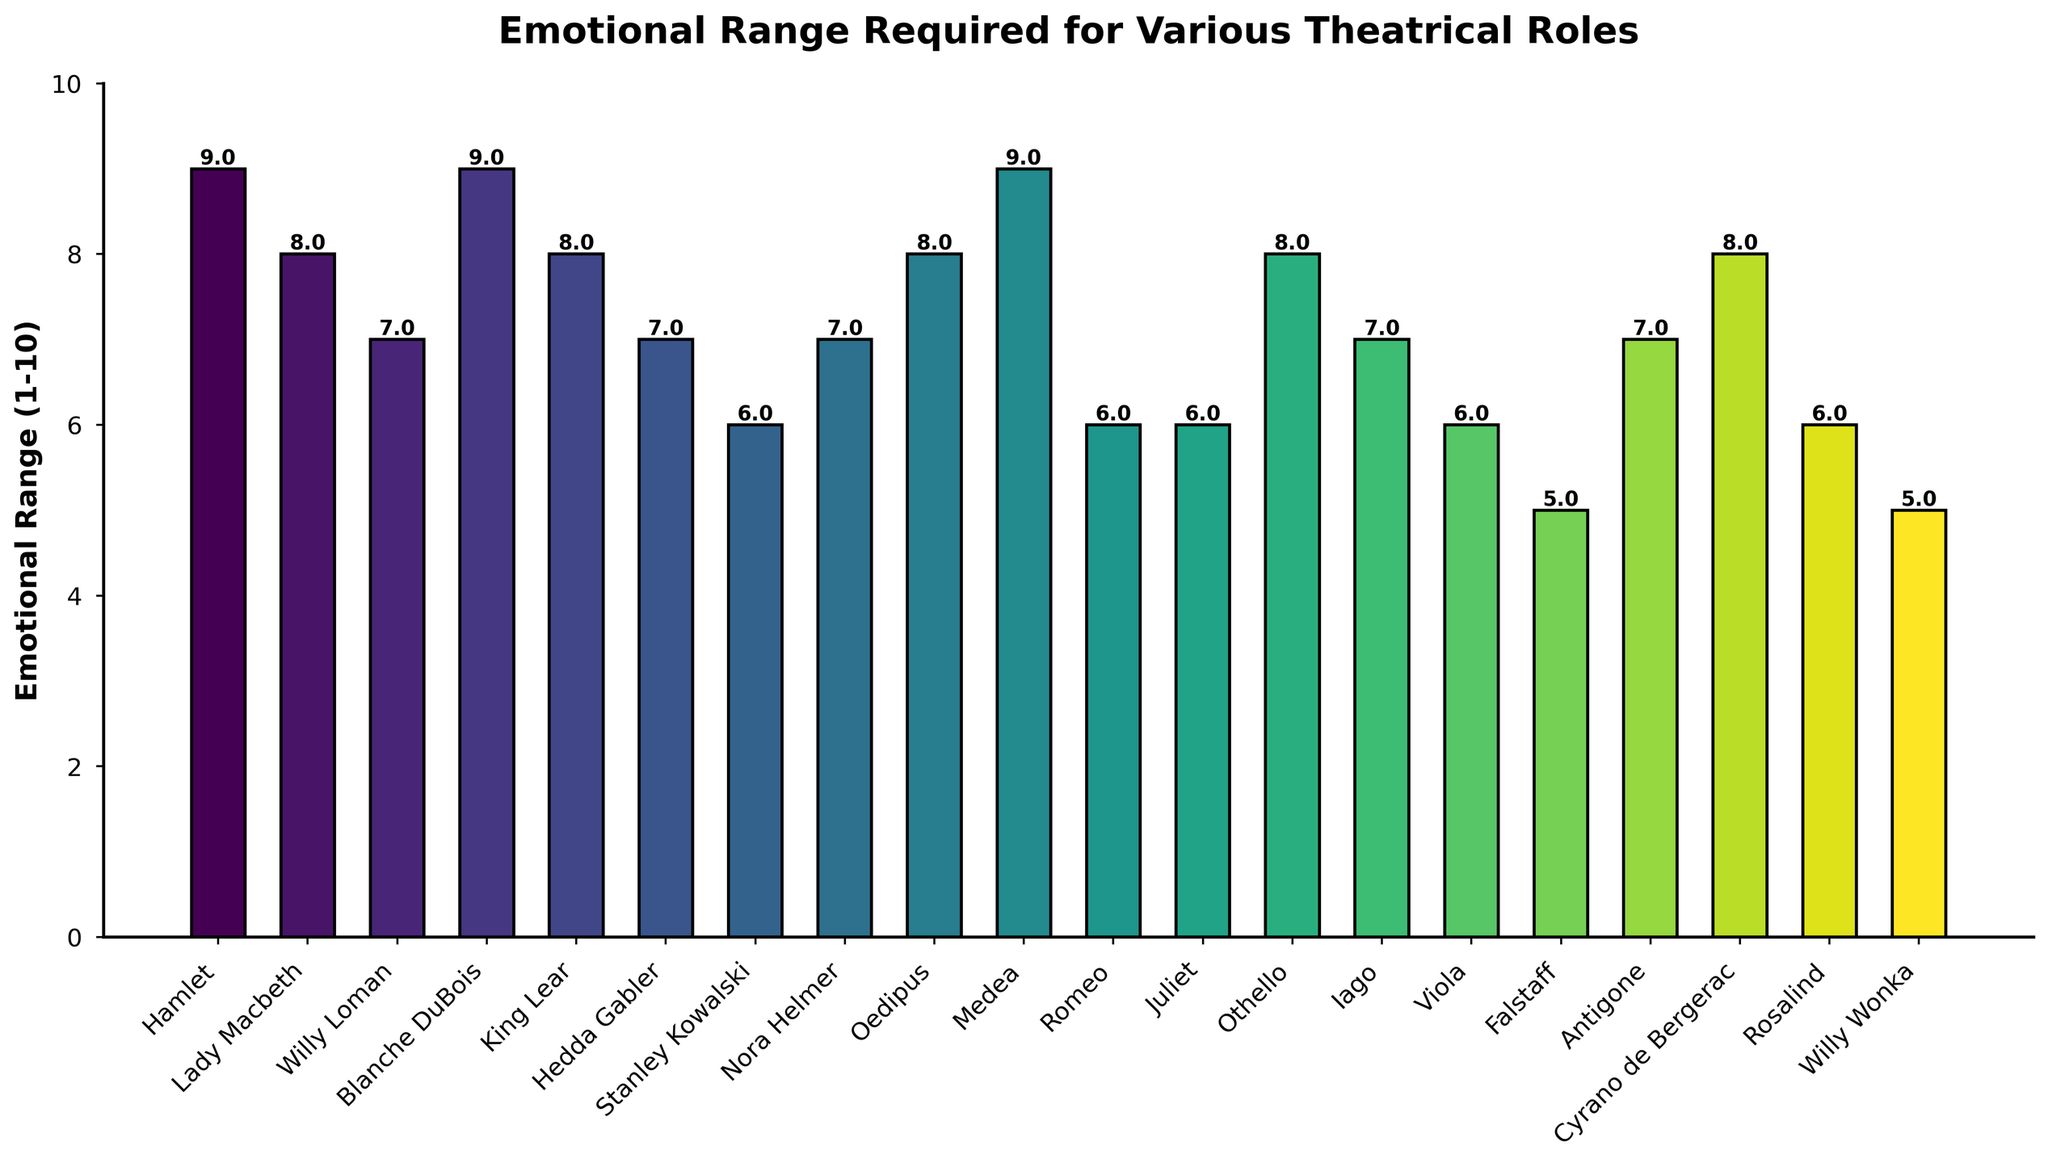which role has the highest emotional range requirement? The bars representing the roles with the highest emotional range are the tallest. The highest emotional range is 9.
Answer: Hamlet, Blanche DuBois, Medea which roles have an emotional range of 6? Identify the bars that reach up to the value of 6 on the y-axis.
Answer: Stanley Kowalski, Romeo, Juliet, Viola, Rosalind how many roles have an emotional range of 8 or higher? Count the number of bars that reach or exceed the value of 8 on the y-axis.
Answer: 7 what is the difference in emotional range between Hamlet and Willy Wonka? Subtract the emotional range of Willy Wonka from that of Hamlet. 9 (Hamlet) - 5 (Willy Wonka) = 4
Answer: 4 which two roles have an emotional range of 5? Identify the bars that reach up to the value of 5 on the y-axis.
Answer: Falstaff, Willy Wonka which role has a higher emotional range: Othello or Iago? Compare the heights of the bars representing Othello and Iago. Othello's bar is higher than Iago's.
Answer: Othello what is the total emotional range for Lady Macbeth, King Lear, and Nora Helmer combined? Sum the emotional ranges of Lady Macbeth (8), King Lear (8), and Nora Helmer (7). 8 + 8 + 7 = 23
Answer: 23 what is the difference in emotional range between the roles with the highest and lowest ranges? Find the difference between the highest emotional range (9) and the lowest emotional range (5). 9 - 5 = 4
Answer: 4 how many roles have an emotional range between 6 and 8, inclusive? Count the number of bars that fall between the values of 6 and 8 on the y-axis, inclusive.
Answer: 9 